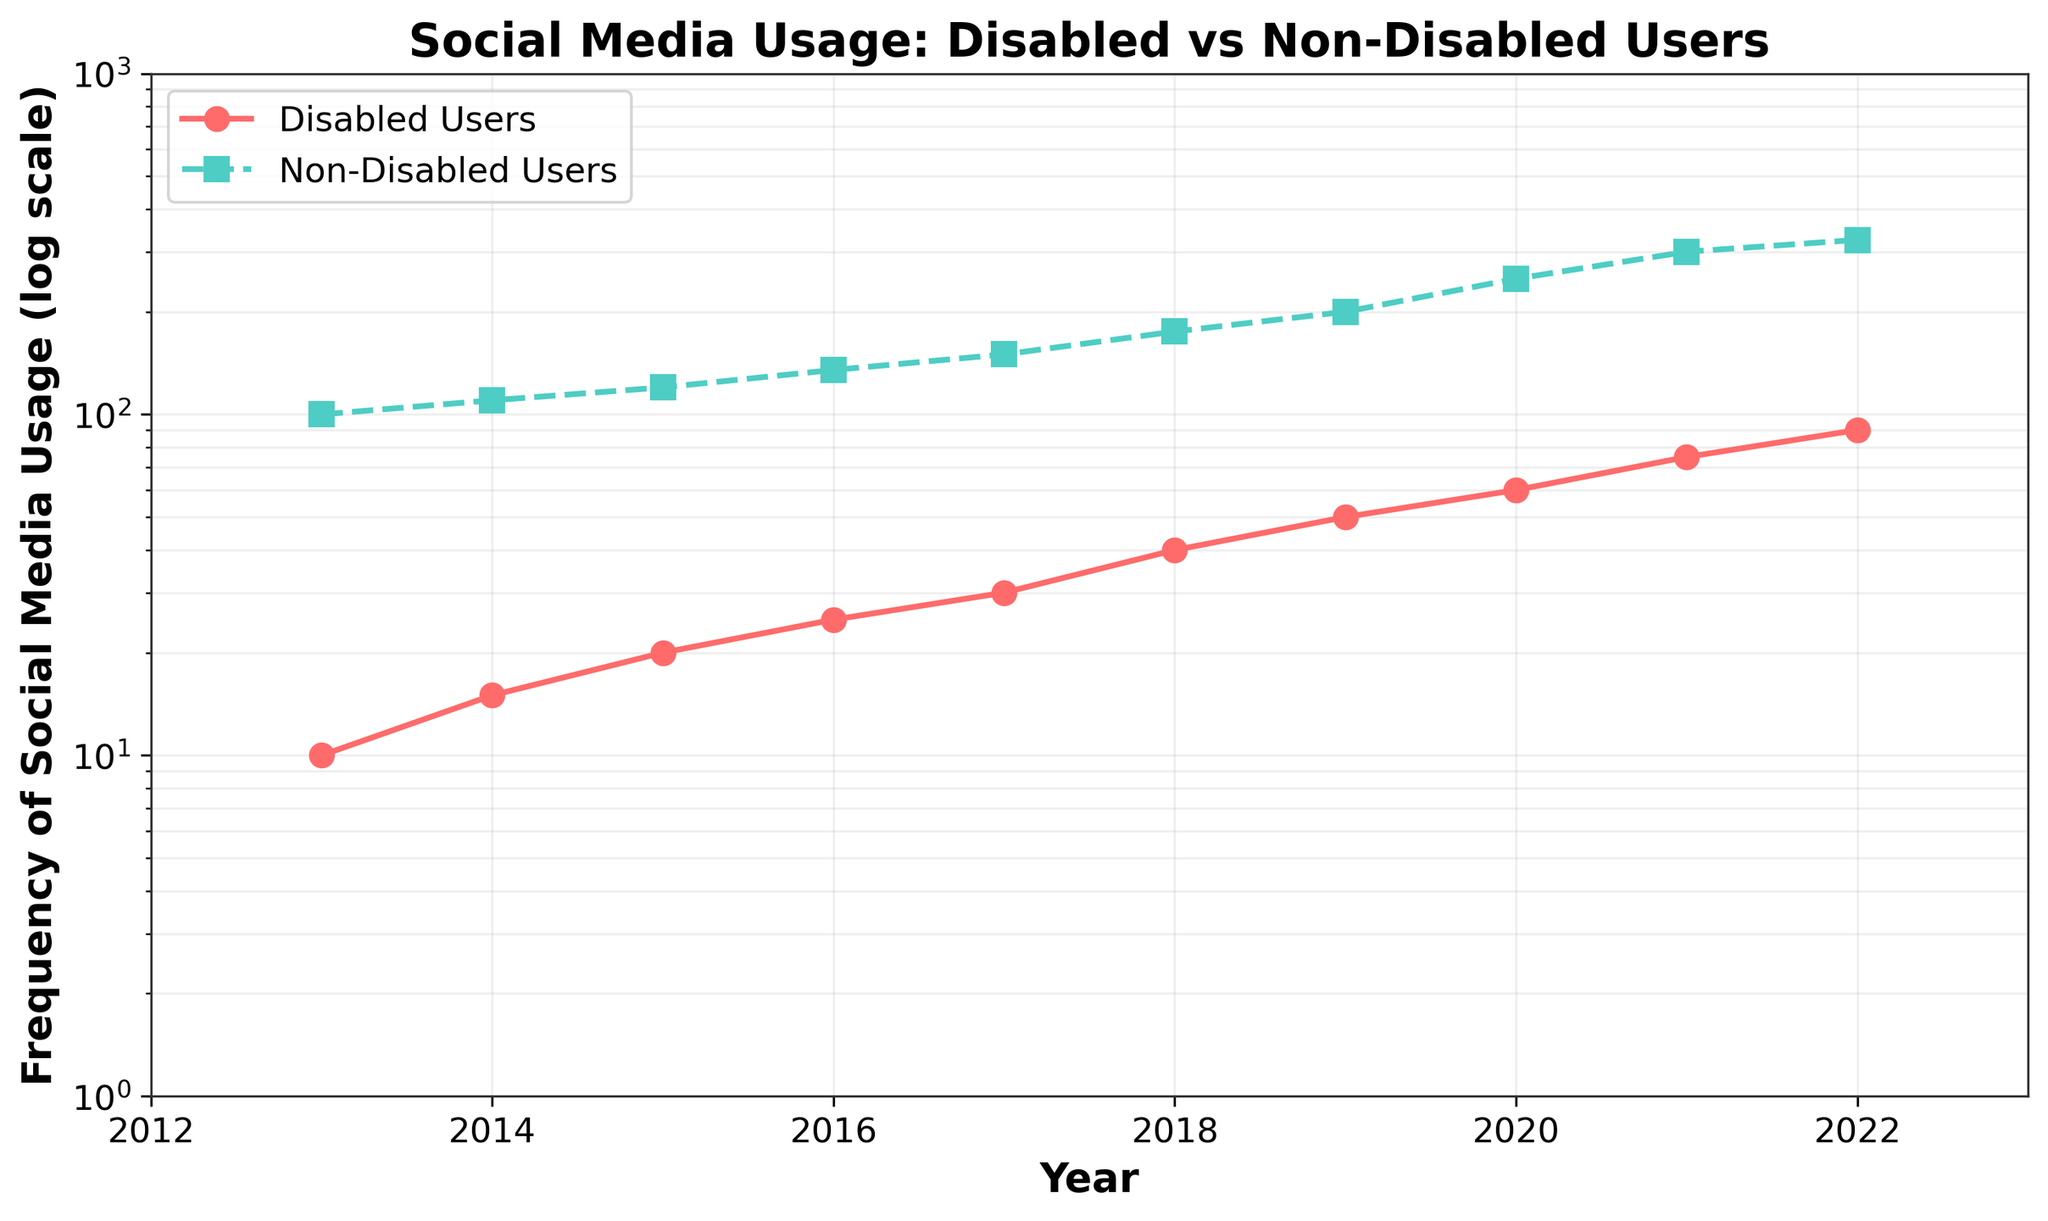What is the title of the figure? The title is positioned at the top of the figure and is bold and large in font size, indicating the overall subject of the data being visualized.
Answer: Social Media Usage: Disabled vs Non-Disabled Users Which user group shows a higher frequency of social media usage in 2016? By looking at the plot lines for 2016, we can observe that the non-disabled users have a higher frequency compared to disabled users, evident by the higher position of the non-disabled line on the y-axis.
Answer: Non-Disabled Users What are the y-axis limits of the figure? The y-axis displays the frequency of social media usage on a log scale, with the lower limit set at 1 and the upper limit set at 1000. This range can be observed along the vertical axis.
Answer: 1 to 1000 By how much did the frequency of social media usage increase for disabled users from 2013 to 2022? To determine this, subtract the 2013 frequency value from the 2022 frequency value for disabled users (90 - 10 = 80).
Answer: 80 What is the frequency of social media usage for non-disabled users in 2018? Locate the data point on the non-disabled users' line corresponding to 2018, which is represented by a green square marker. The value is approximately 175.
Answer: 175 How does the trend in social media usage for disabled users compare to non-disabled users over the years? By examining the plot, we see that both user groups exhibit an upward trend in social media usage. However, the frequency of non-disabled users is consistently higher than that of disabled users each year.
Answer: Non-disabled users consistently higher, both increasing What is the overall trend in social media usage for both user groups over the last 10 years? The plot shows that both disabled and non-disabled users have experienced a continuous upward trend in social media usage from 2013 to 2022. This is indicated by the increasing values on the log scale.
Answer: Upward trend In which year did the frequency of social media usage for disabled users surpass 50? By identifying the point on the disabled users’ line where the value first exceeds 50, we can see this happens in 2019.
Answer: 2019 What is the difference in social media usage frequency between the two groups in 2021? Locate the 2021 data points for both disabled and non-disabled users and subtract the frequency of disabled users from the frequency of non-disabled users (300 - 75 = 225).
Answer: 225 